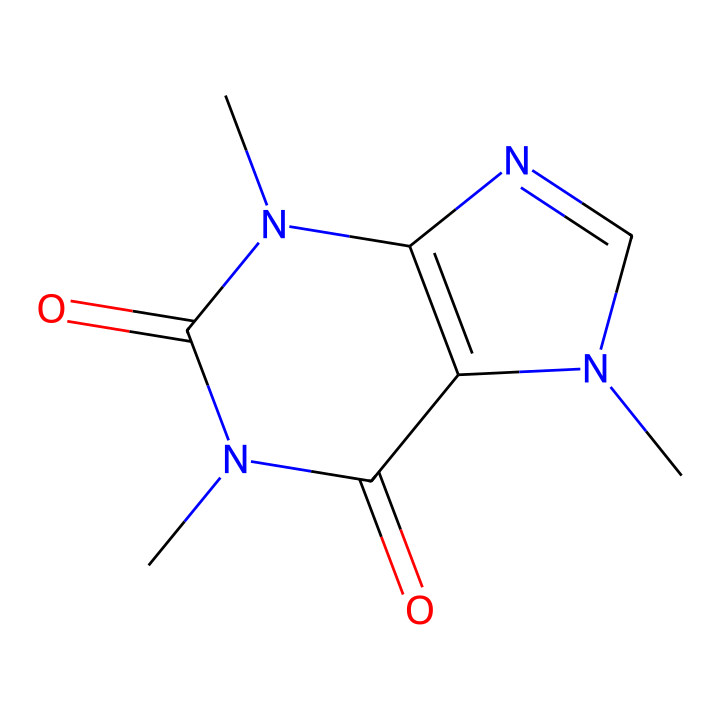What is the molecular formula of this chemical? To find the molecular formula, we identify the types and numbers of atoms present in the chemical structure. The SMILES representation indicates the presence of carbon (C), nitrogen (N), and oxygen (O) atoms. Counting these yields: 8 carbon atoms, 10 hydrogen atoms, 4 nitrogen atoms, and 2 oxygen atoms. Combining these gives the formula C8H10N4O2.
Answer: C8H10N4O2 How many rings are in the structure? Analyzing the SMILES representation, we see the presence of two ring systems indicated by the numbering of the atoms. Each number marks connectivity, forming what visually appears as two distinct cyclic structures. Hence, there are two rings in this chemical.
Answer: 2 What type of drug is this compound classified as? This compound is classified as a stimulant drug. Stimulants typically enhance brain activity and alertness. Analyzing the structure shows it is related to caffeine, which is known for its stimulating effects.
Answer: stimulant How many nitrogen atoms are present? By examining the SMILES representation closely, we can count the nitrogen (N) atoms indicated by the "N" notation. There are four "N" notations present throughout the structure. Therefore, the count of nitrogen atoms is four.
Answer: 4 Which part of the chemical structure is primarily responsible for its stimulating effects? In this chemical structure, the presence of nitrogen atoms in a specific arrangement is crucial. The nitrogen heterocycles play an essential role in binding to adenosine receptors in the brain, leading to increased alertness and decreased fatigue. Hence, the nitrogen atoms in the rings cause the stimulating effects.
Answer: nitrogen atoms What is the characteristic feature of this class of drugs related to their chemical structure? This drug class, which caffeine belongs to, is characterized by the presence of multiple nitrogen atoms in a heterocyclic compound structure. This can be deduced from the SMILES representation, reflecting typical features of stimulants that interact with the brain's neurotransmitters.
Answer: nitrogen heterocycles 